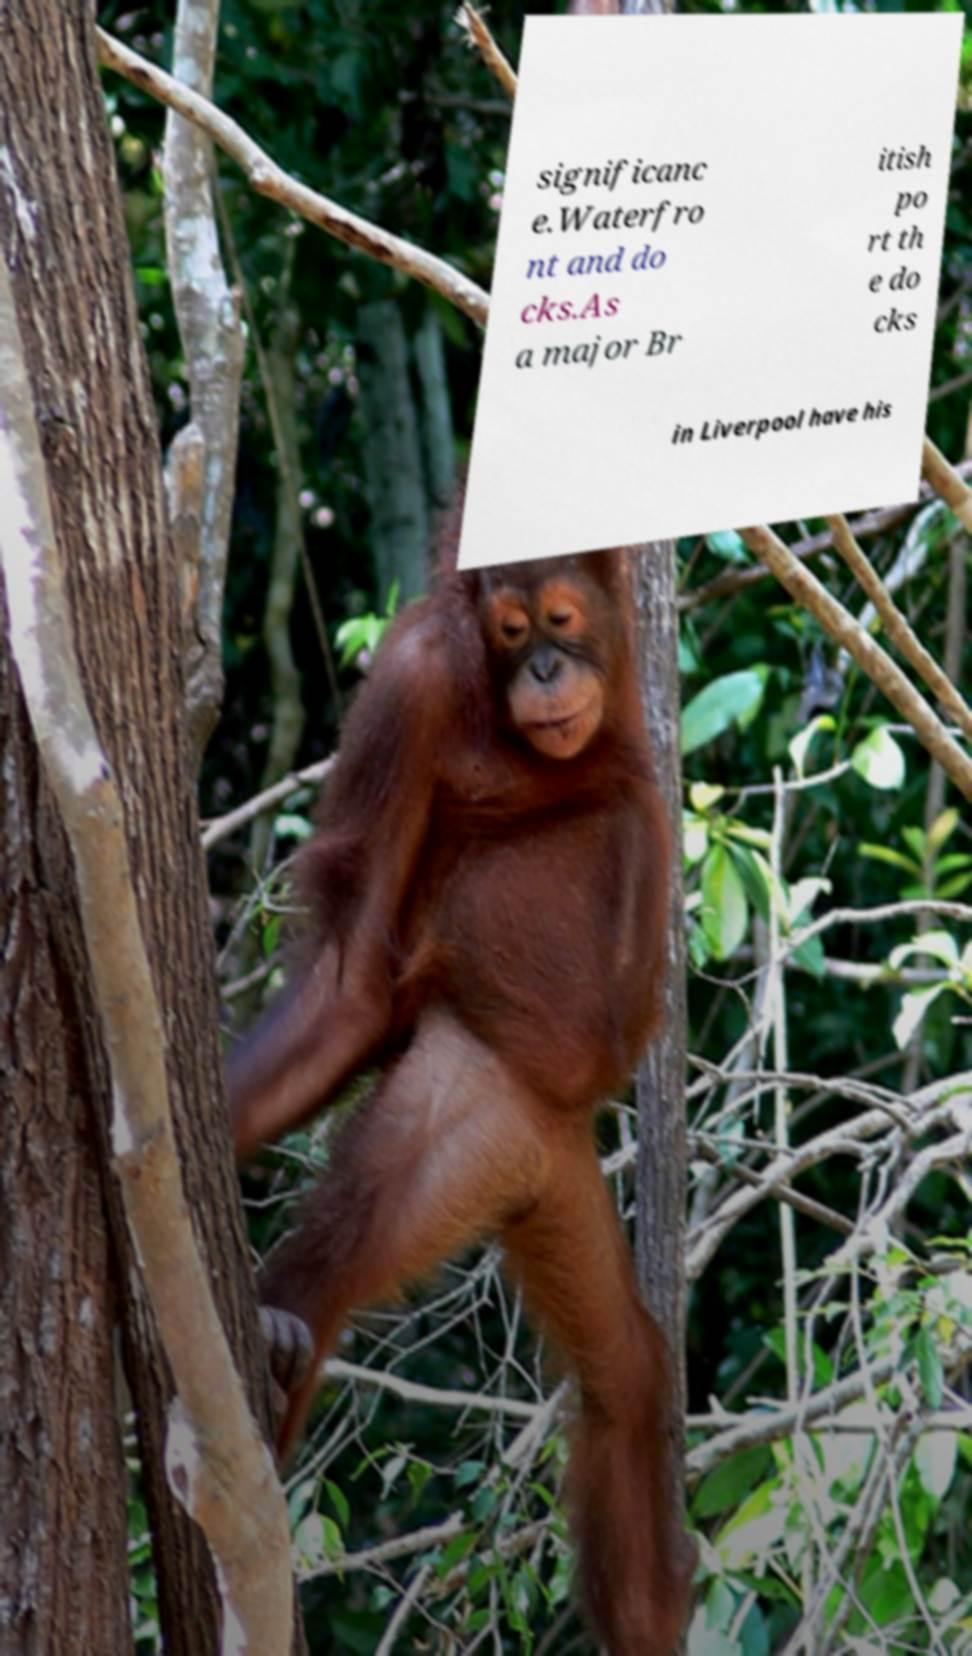Could you assist in decoding the text presented in this image and type it out clearly? significanc e.Waterfro nt and do cks.As a major Br itish po rt th e do cks in Liverpool have his 